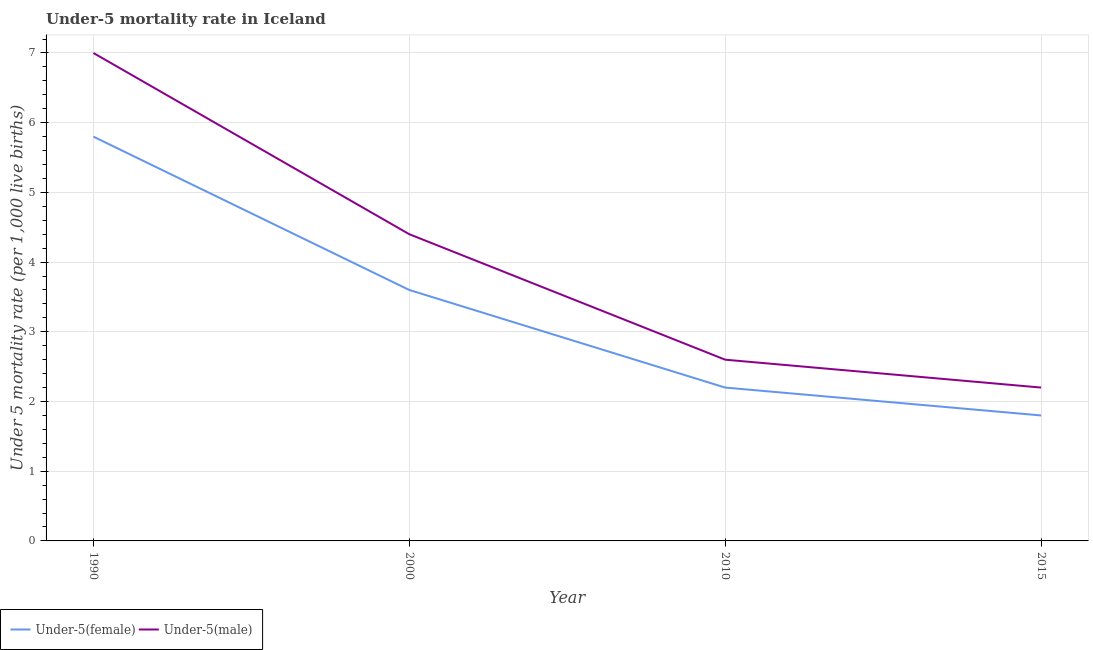Is the number of lines equal to the number of legend labels?
Offer a very short reply. Yes. What is the under-5 male mortality rate in 2010?
Your response must be concise. 2.6. In which year was the under-5 male mortality rate minimum?
Keep it short and to the point. 2015. What is the total under-5 female mortality rate in the graph?
Ensure brevity in your answer.  13.4. What is the difference between the under-5 female mortality rate in 1990 and that in 2010?
Give a very brief answer. 3.6. What is the average under-5 male mortality rate per year?
Your answer should be compact. 4.05. In the year 2000, what is the difference between the under-5 female mortality rate and under-5 male mortality rate?
Your response must be concise. -0.8. In how many years, is the under-5 male mortality rate greater than 3.4?
Give a very brief answer. 2. What is the ratio of the under-5 male mortality rate in 2000 to that in 2010?
Offer a terse response. 1.69. Is the difference between the under-5 male mortality rate in 1990 and 2015 greater than the difference between the under-5 female mortality rate in 1990 and 2015?
Offer a terse response. Yes. What is the difference between the highest and the second highest under-5 male mortality rate?
Offer a terse response. 2.6. What is the difference between the highest and the lowest under-5 male mortality rate?
Keep it short and to the point. 4.8. In how many years, is the under-5 male mortality rate greater than the average under-5 male mortality rate taken over all years?
Provide a short and direct response. 2. Is the under-5 male mortality rate strictly greater than the under-5 female mortality rate over the years?
Ensure brevity in your answer.  Yes. Is the under-5 female mortality rate strictly less than the under-5 male mortality rate over the years?
Provide a short and direct response. Yes. Does the graph contain any zero values?
Your answer should be compact. No. What is the title of the graph?
Give a very brief answer. Under-5 mortality rate in Iceland. Does "Male population" appear as one of the legend labels in the graph?
Your response must be concise. No. What is the label or title of the X-axis?
Your answer should be very brief. Year. What is the label or title of the Y-axis?
Make the answer very short. Under 5 mortality rate (per 1,0 live births). What is the Under 5 mortality rate (per 1,000 live births) in Under-5(female) in 1990?
Your answer should be compact. 5.8. What is the Under 5 mortality rate (per 1,000 live births) in Under-5(female) in 2000?
Offer a terse response. 3.6. What is the Under 5 mortality rate (per 1,000 live births) in Under-5(female) in 2010?
Give a very brief answer. 2.2. What is the Under 5 mortality rate (per 1,000 live births) in Under-5(male) in 2010?
Ensure brevity in your answer.  2.6. Across all years, what is the minimum Under 5 mortality rate (per 1,000 live births) in Under-5(female)?
Your answer should be compact. 1.8. What is the difference between the Under 5 mortality rate (per 1,000 live births) in Under-5(male) in 1990 and that in 2000?
Your response must be concise. 2.6. What is the difference between the Under 5 mortality rate (per 1,000 live births) in Under-5(female) in 2000 and that in 2015?
Your answer should be compact. 1.8. What is the difference between the Under 5 mortality rate (per 1,000 live births) in Under-5(female) in 2010 and that in 2015?
Ensure brevity in your answer.  0.4. What is the difference between the Under 5 mortality rate (per 1,000 live births) in Under-5(male) in 2010 and that in 2015?
Give a very brief answer. 0.4. What is the difference between the Under 5 mortality rate (per 1,000 live births) in Under-5(female) in 1990 and the Under 5 mortality rate (per 1,000 live births) in Under-5(male) in 2000?
Provide a succinct answer. 1.4. What is the difference between the Under 5 mortality rate (per 1,000 live births) of Under-5(female) in 1990 and the Under 5 mortality rate (per 1,000 live births) of Under-5(male) in 2010?
Keep it short and to the point. 3.2. What is the difference between the Under 5 mortality rate (per 1,000 live births) of Under-5(female) in 1990 and the Under 5 mortality rate (per 1,000 live births) of Under-5(male) in 2015?
Keep it short and to the point. 3.6. What is the difference between the Under 5 mortality rate (per 1,000 live births) in Under-5(female) in 2000 and the Under 5 mortality rate (per 1,000 live births) in Under-5(male) in 2015?
Your answer should be compact. 1.4. What is the difference between the Under 5 mortality rate (per 1,000 live births) in Under-5(female) in 2010 and the Under 5 mortality rate (per 1,000 live births) in Under-5(male) in 2015?
Make the answer very short. 0. What is the average Under 5 mortality rate (per 1,000 live births) of Under-5(female) per year?
Make the answer very short. 3.35. What is the average Under 5 mortality rate (per 1,000 live births) of Under-5(male) per year?
Your answer should be compact. 4.05. In the year 1990, what is the difference between the Under 5 mortality rate (per 1,000 live births) in Under-5(female) and Under 5 mortality rate (per 1,000 live births) in Under-5(male)?
Make the answer very short. -1.2. In the year 2015, what is the difference between the Under 5 mortality rate (per 1,000 live births) in Under-5(female) and Under 5 mortality rate (per 1,000 live births) in Under-5(male)?
Keep it short and to the point. -0.4. What is the ratio of the Under 5 mortality rate (per 1,000 live births) of Under-5(female) in 1990 to that in 2000?
Keep it short and to the point. 1.61. What is the ratio of the Under 5 mortality rate (per 1,000 live births) in Under-5(male) in 1990 to that in 2000?
Your answer should be compact. 1.59. What is the ratio of the Under 5 mortality rate (per 1,000 live births) of Under-5(female) in 1990 to that in 2010?
Offer a terse response. 2.64. What is the ratio of the Under 5 mortality rate (per 1,000 live births) in Under-5(male) in 1990 to that in 2010?
Ensure brevity in your answer.  2.69. What is the ratio of the Under 5 mortality rate (per 1,000 live births) of Under-5(female) in 1990 to that in 2015?
Provide a short and direct response. 3.22. What is the ratio of the Under 5 mortality rate (per 1,000 live births) of Under-5(male) in 1990 to that in 2015?
Provide a succinct answer. 3.18. What is the ratio of the Under 5 mortality rate (per 1,000 live births) of Under-5(female) in 2000 to that in 2010?
Offer a very short reply. 1.64. What is the ratio of the Under 5 mortality rate (per 1,000 live births) in Under-5(male) in 2000 to that in 2010?
Keep it short and to the point. 1.69. What is the ratio of the Under 5 mortality rate (per 1,000 live births) of Under-5(female) in 2010 to that in 2015?
Your answer should be very brief. 1.22. What is the ratio of the Under 5 mortality rate (per 1,000 live births) in Under-5(male) in 2010 to that in 2015?
Provide a succinct answer. 1.18. What is the difference between the highest and the second highest Under 5 mortality rate (per 1,000 live births) of Under-5(male)?
Your answer should be very brief. 2.6. 